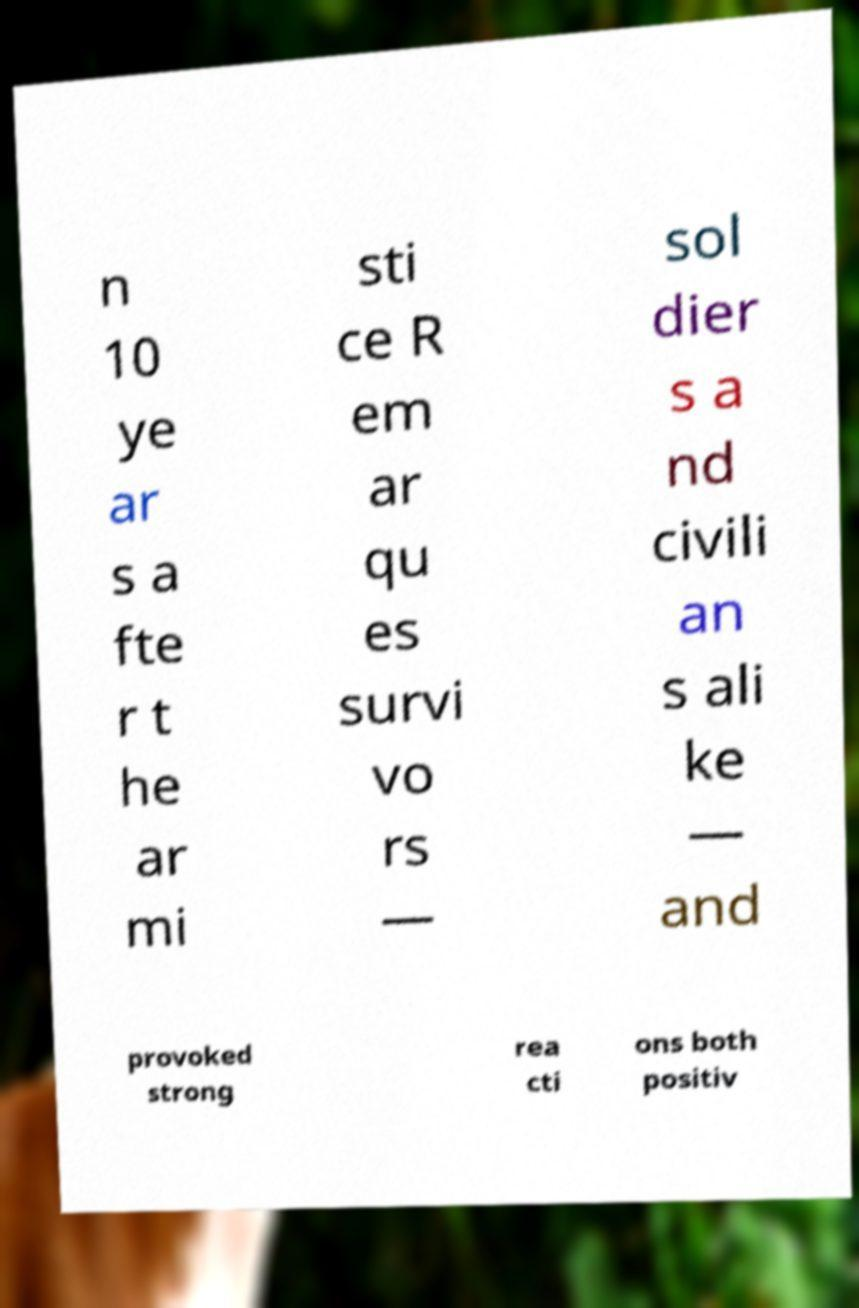Could you assist in decoding the text presented in this image and type it out clearly? n 10 ye ar s a fte r t he ar mi sti ce R em ar qu es survi vo rs — sol dier s a nd civili an s ali ke — and provoked strong rea cti ons both positiv 